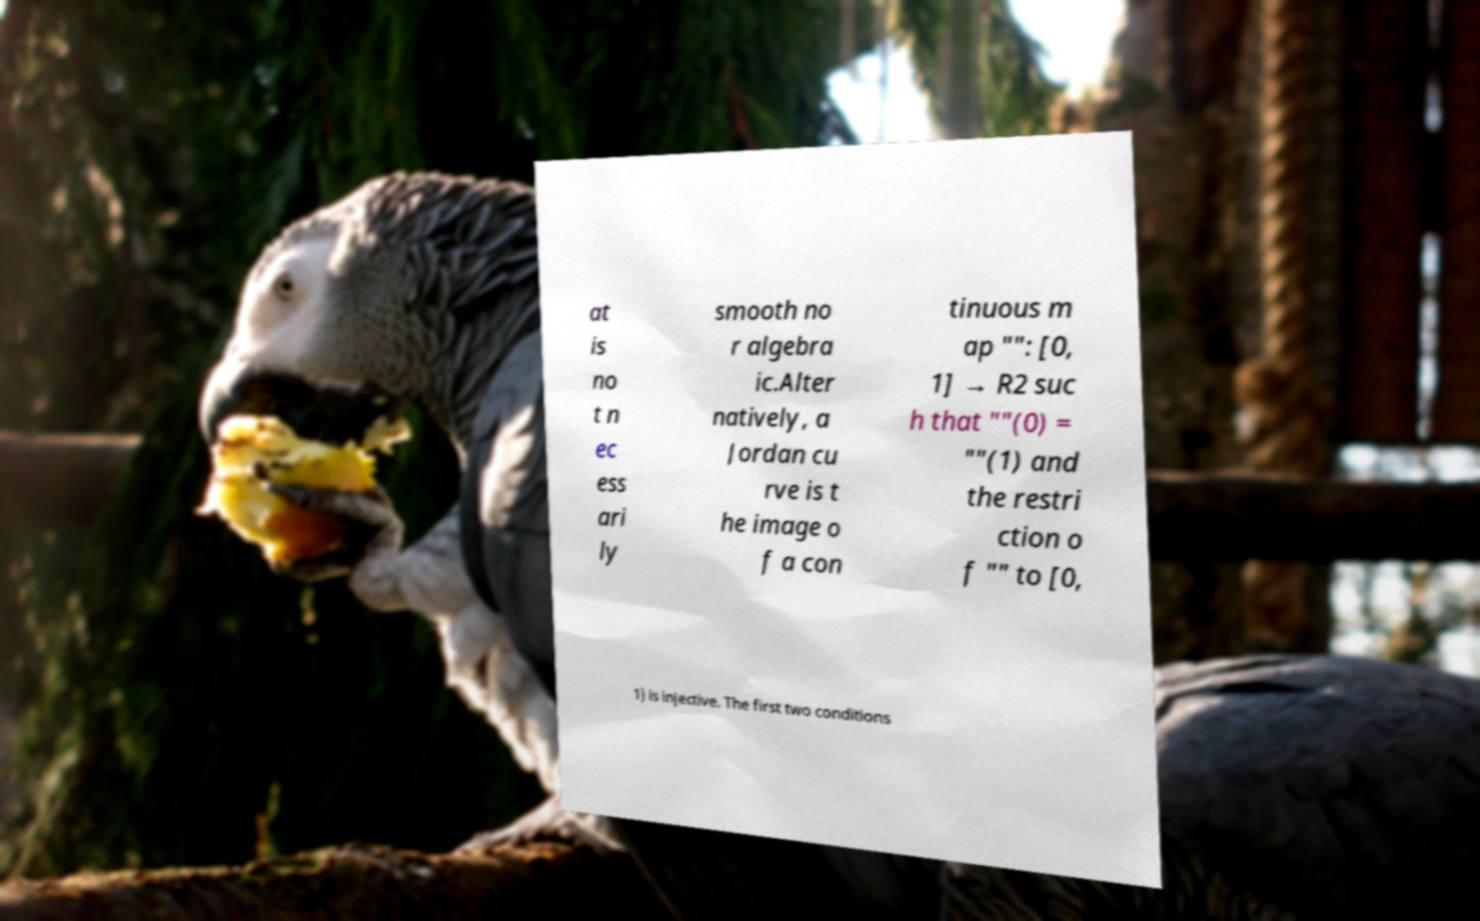Please identify and transcribe the text found in this image. at is no t n ec ess ari ly smooth no r algebra ic.Alter natively, a Jordan cu rve is t he image o f a con tinuous m ap "": [0, 1] → R2 suc h that ""(0) = ""(1) and the restri ction o f "" to [0, 1) is injective. The first two conditions 